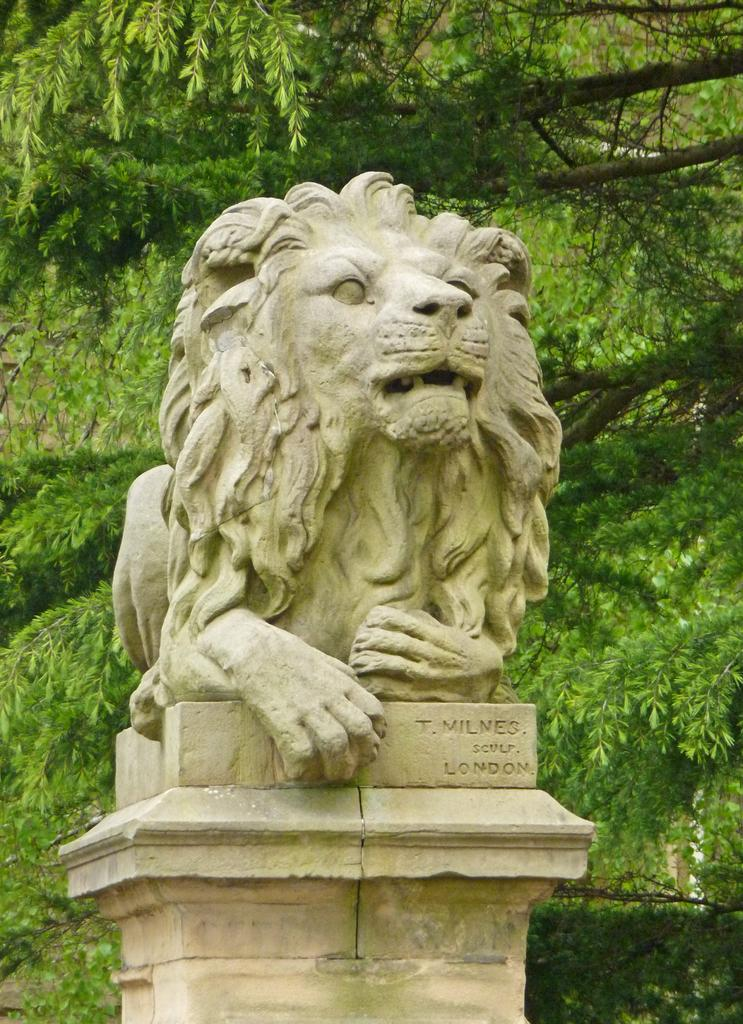What is the main subject of the image? There is a statue of an animal in the image. How is the statue positioned in the image? The statue is on a pedestal. What can be seen in the background of the image? There are trees in the background of the image. What type of hand can be seen holding the statue in the image? There is no hand holding the statue in the image; it is on a pedestal. What type of gate is visible in the image? There is no gate present in the image. 